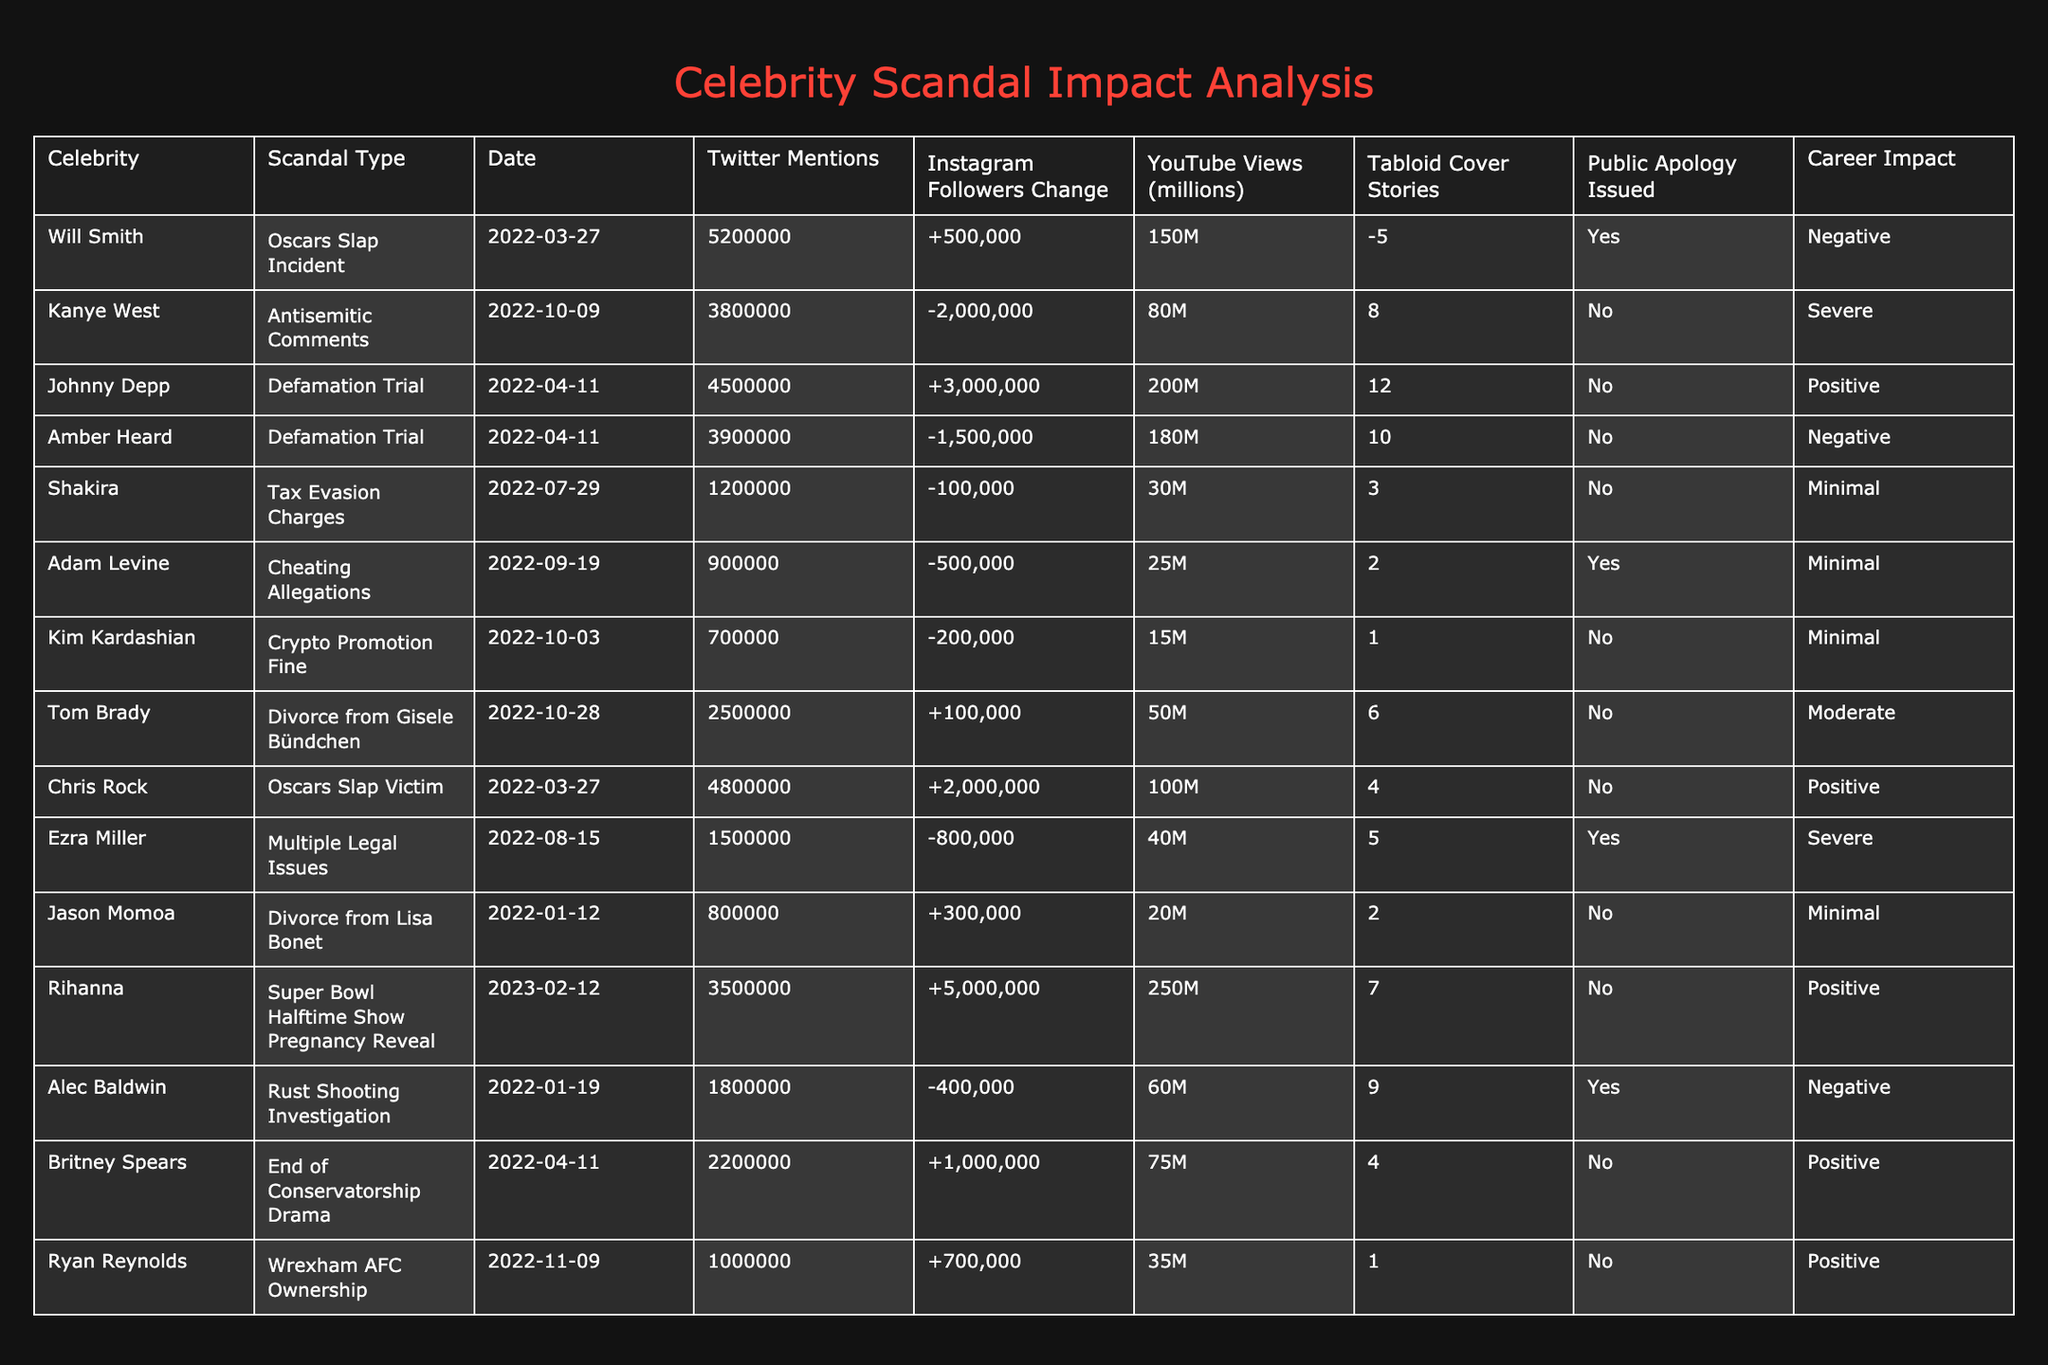How many Twitter mentions did Kanye West receive? From the table, Kanye West's Twitter mentions are specifically listed under the "Twitter Mentions" column. The value there is 3,800,000.
Answer: 3,800,000 What is the Instagram followers change for Will Smith? Looking at the table, Will Smith has an Instagram followers change of +500,000, which is clearly specified in the "Instagram Followers Change" column.
Answer: +500,000 Which celebrity had the highest YouTube views related to their scandal? In the "YouTube Views (millions)" column, we can compare all values and see that Johnny Depp had the highest count with 200 million views.
Answer: Johnny Depp Did Amber Heard issue a public apology? The table indicates in the "Public Apology Issued" column that Amber Heard did not issue an apology ("No").
Answer: No What is the total number of tabloid cover stories for scandals involving Amber Heard and Alec Baldwin? Amber Heard had 10 tabloid covers and Alec Baldwin had 9. Summing these values (10 + 9) gives us a total of 19 cover stories.
Answer: 19 Which scandal had a positive career impact for Chris Rock? The "Career Impact" column shows that Chris Rock had a positive career impact from the "Oscars Slap Victim" incident. It's indicated as "Positive".
Answer: Positive How many celebrities had negative career impacts according to the table? Going through the "Career Impact" column, we can count how many entries are labeled as "Negative": Will Smith, Kanye West, Amber Heard, and Alec Baldwin. This totals 4 celebrities.
Answer: 4 What was the difference in Twitter mentions between Will Smith and Britney Spears? Will Smith had 5,200,000 mentions while Britney Spears had 2,200,000 mentions. The difference is calculated by subtracting the two: 5,200,000 - 2,200,000 = 3,000,000.
Answer: 3,000,000 Who had the most significant change in Instagram followers, and what was the amount? The table shows that Kanye West had the most significant change with -2,000,000 followers. This is the largest decrease among all celebrities listed.
Answer: Kanye West, -2,000,000 What percentage of celebrities in the table issued a public apology? There are 14 celebrities listed, of which 3 issued public apologies (Will Smith, Adam Levine, Ezra Miller). The percentage is (3/14) * 100, which is approximately 21.43%.
Answer: 21.43% 